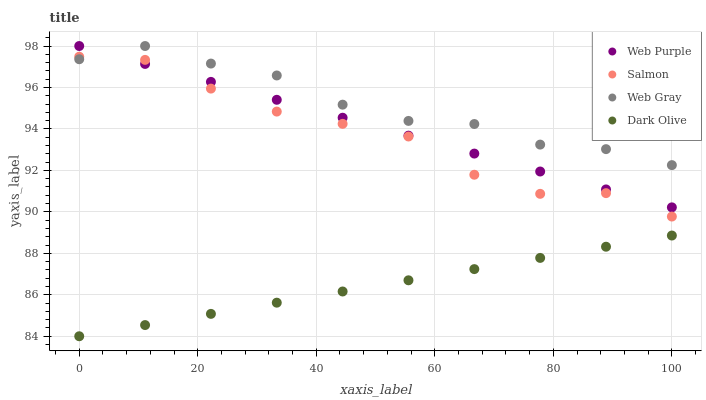Does Dark Olive have the minimum area under the curve?
Answer yes or no. Yes. Does Web Gray have the maximum area under the curve?
Answer yes or no. Yes. Does Web Purple have the minimum area under the curve?
Answer yes or no. No. Does Web Purple have the maximum area under the curve?
Answer yes or no. No. Is Web Purple the smoothest?
Answer yes or no. Yes. Is Salmon the roughest?
Answer yes or no. Yes. Is Web Gray the smoothest?
Answer yes or no. No. Is Web Gray the roughest?
Answer yes or no. No. Does Dark Olive have the lowest value?
Answer yes or no. Yes. Does Web Purple have the lowest value?
Answer yes or no. No. Does Web Gray have the highest value?
Answer yes or no. Yes. Does Salmon have the highest value?
Answer yes or no. No. Is Dark Olive less than Salmon?
Answer yes or no. Yes. Is Web Purple greater than Dark Olive?
Answer yes or no. Yes. Does Web Gray intersect Web Purple?
Answer yes or no. Yes. Is Web Gray less than Web Purple?
Answer yes or no. No. Is Web Gray greater than Web Purple?
Answer yes or no. No. Does Dark Olive intersect Salmon?
Answer yes or no. No. 